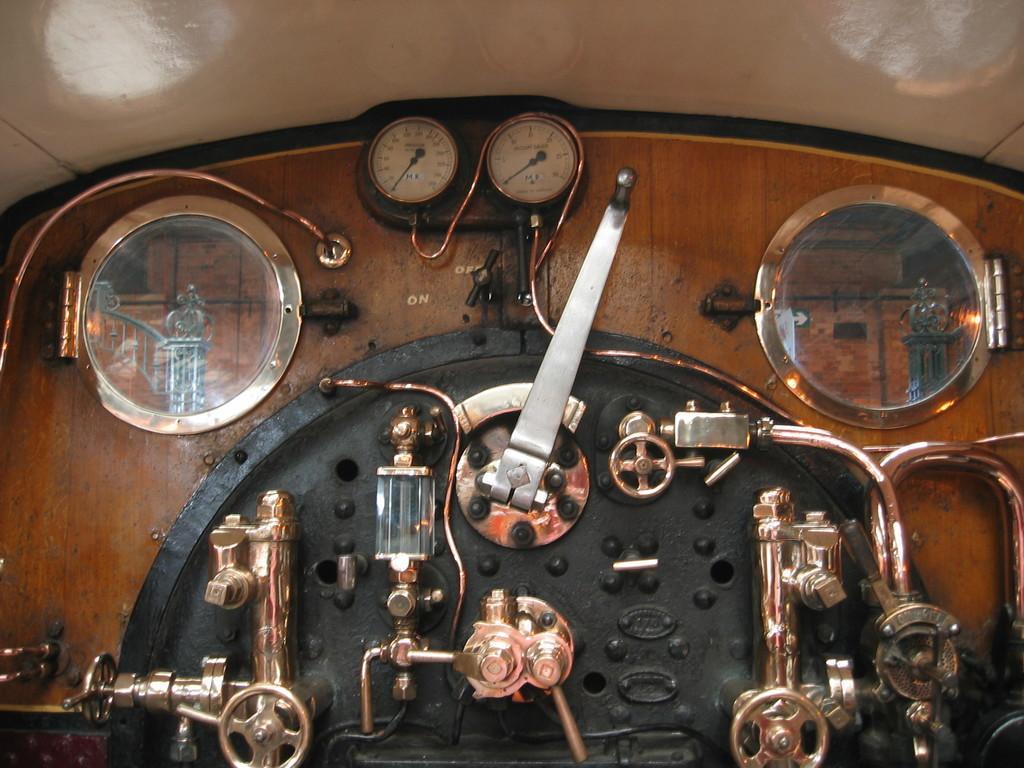How would you summarize this image in a sentence or two? In this image we can see a machine. At the top of the image we can see the roof. 